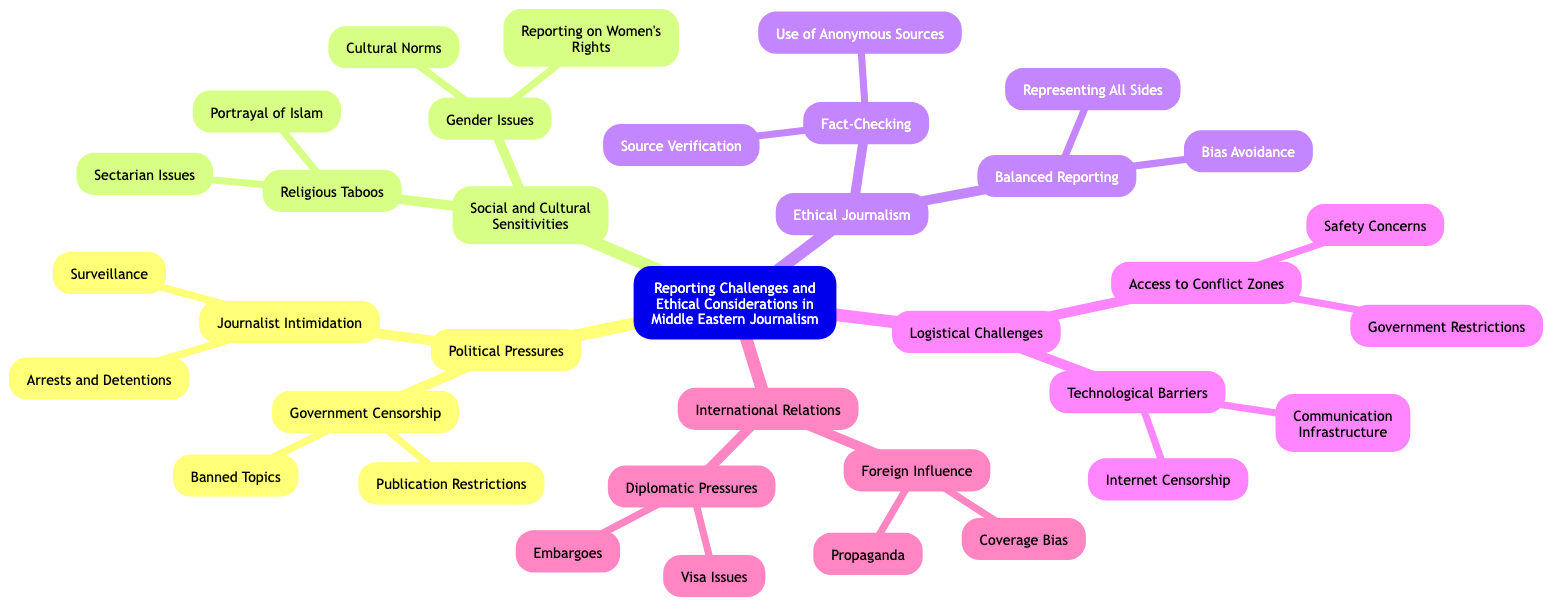What is the central node of the diagram? The central node is the main topic of the mind map, which can be found at the center of the structure. According to the provided data, it is "Reporting Challenges and Ethical Considerations in Middle Eastern Journalism."
Answer: Reporting Challenges and Ethical Considerations in Middle Eastern Journalism How many branches are there in the diagram? The branches represent the major categories related to the central node. Counting the branches listed, there are five main branches: Political Pressures, Social and Cultural Sensitivities, Ethical Journalism, Logistical Challenges, and International Relations.
Answer: 5 What are the subnodes under Political Pressures? To find the subnodes under Political Pressures, you go to that branch in the mind map and look at the nodes listed underneath. The subnodes are Government Censorship and Journalist Intimidation.
Answer: Government Censorship, Journalist Intimidation Which node discusses reporting on Gender Issues? The phrase "Gender Issues" directly refers to a specific subnode within the Social and Cultural Sensitivities branch. By organizing the branches, we see that it is indeed present under that particular category.
Answer: Gender Issues What are the two aspects of Ethical Journalism mentioned in the diagram? The diagram states that Ethical Journalism encompasses Fact-Checking and Balanced Reporting. By reviewing that branch, these two aspects are clearly outlined subnodes.
Answer: Fact-Checking, Balanced Reporting Which subnode addresses the issue of Internet Censorship? To answer this question, one would need to locate the "Technological Barriers" subnode under the Logistical Challenges branch, which lists Internet Censorship as one of its subnodes.
Answer: Internet Censorship How does Foreign Influence relate to Coverage Bias? This requires understanding the relationship between the nodes in the International Relations branch. Foreign Influence is a broader concept under which Coverage Bias falls as one of its subnodes, indicating a dependent relationship.
Answer: Foreign Influence -> Coverage Bias What are the two subnodes related to Government Censorship? The subnodes can be identified by locating the Government Censorship node and examining its children directly. It specifically includes Publication Restrictions and Banned Topics.
Answer: Publication Restrictions, Banned Topics What forces might affect journalists reporting in conflict zones according to the diagram? Looking at the Access to Conflict Zones node under Logistical Challenges, we can infer that Safety Concerns and Government Restrictions could directly impact journalists in these areas.
Answer: Safety Concerns, Government Restrictions 